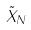<formula> <loc_0><loc_0><loc_500><loc_500>\tilde { X } _ { N }</formula> 